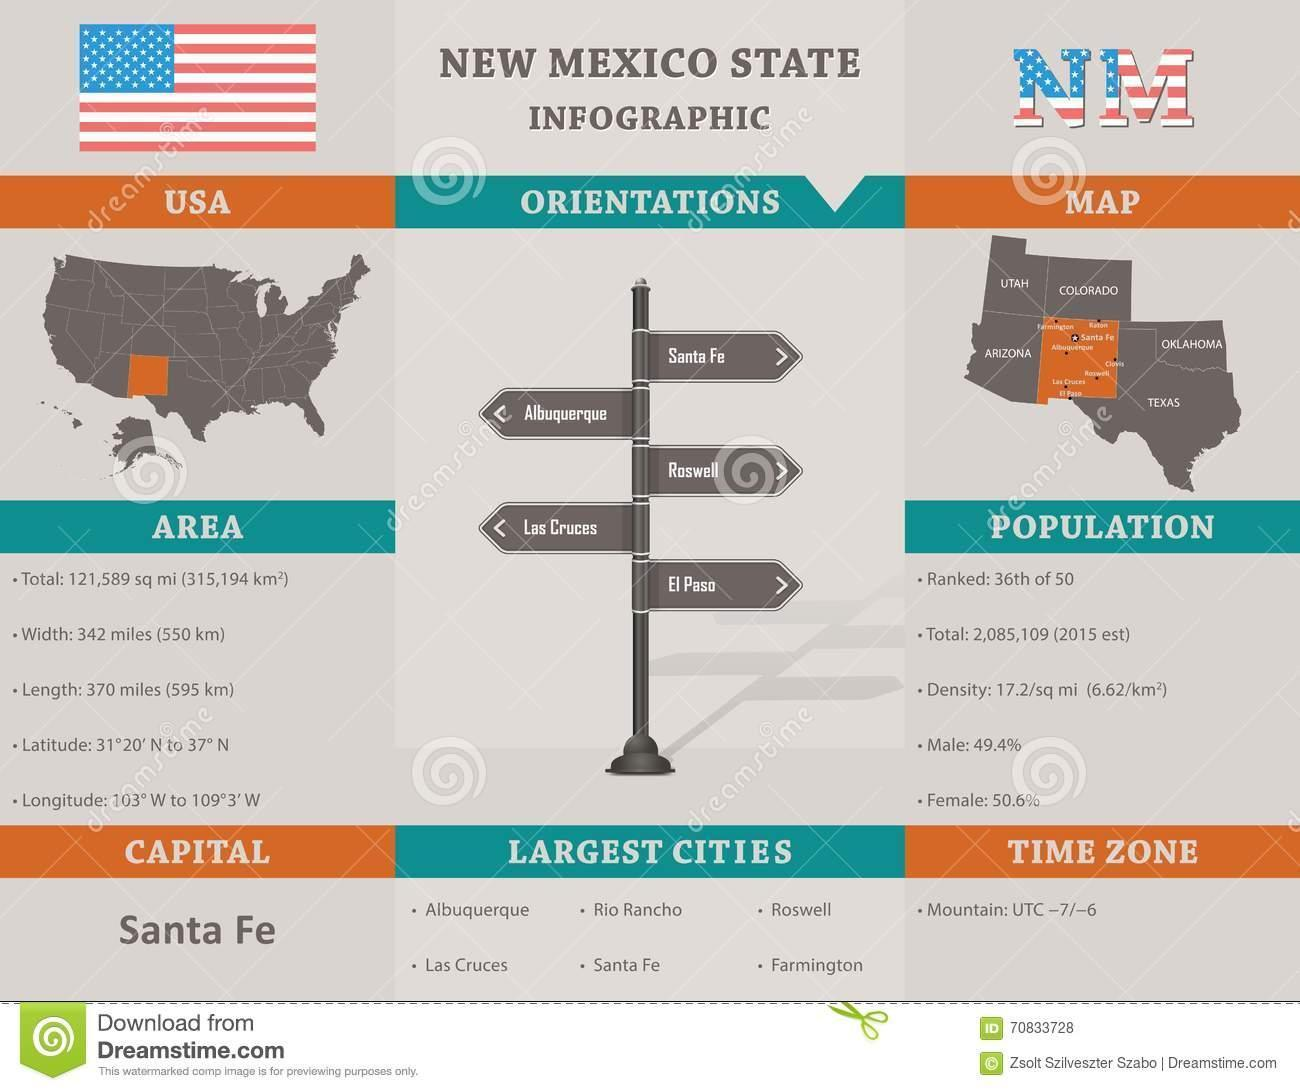What is the number of big cities in New Mexico State?
Answer the question with a short phrase. 6 How many orientations for New Mexico state? 5 How many time zones in New Mexico state? 1 